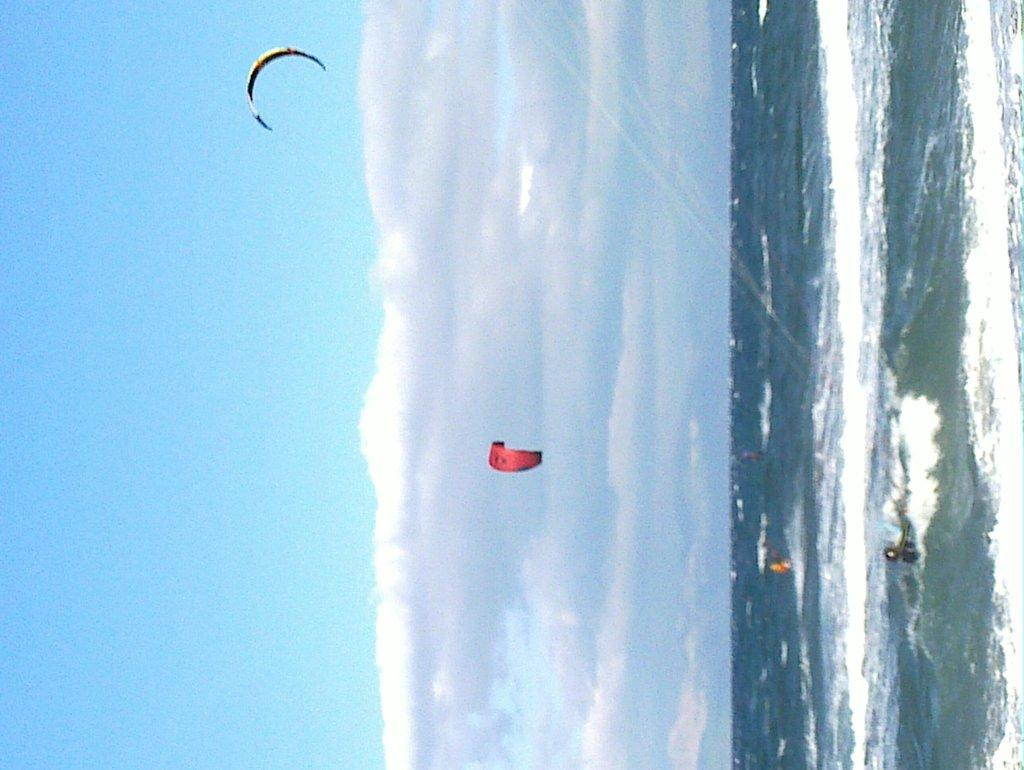What are the two people doing in the image? There are two paragliders flying in the air in the image. What is happening on the right side of the image? There is a person in the water on the right side of the image. What can be seen in the background of the image? The sky is visible in the background of the image. What type of trade is being conducted in the image? There is no trade being conducted in the image; it features two paragliders flying in the air and a person in the water. Can you see any quince trees in the image? There are no quince trees present in the image. 